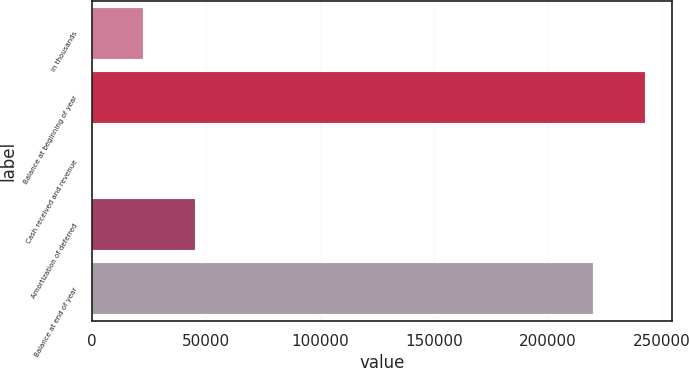Convert chart. <chart><loc_0><loc_0><loc_500><loc_500><bar_chart><fcel>in thousands<fcel>Balance at beginning of year<fcel>Cash received and revenue<fcel>Amortization of deferred<fcel>Balance at end of year<nl><fcel>22642.6<fcel>242424<fcel>187<fcel>45098.2<fcel>219968<nl></chart> 